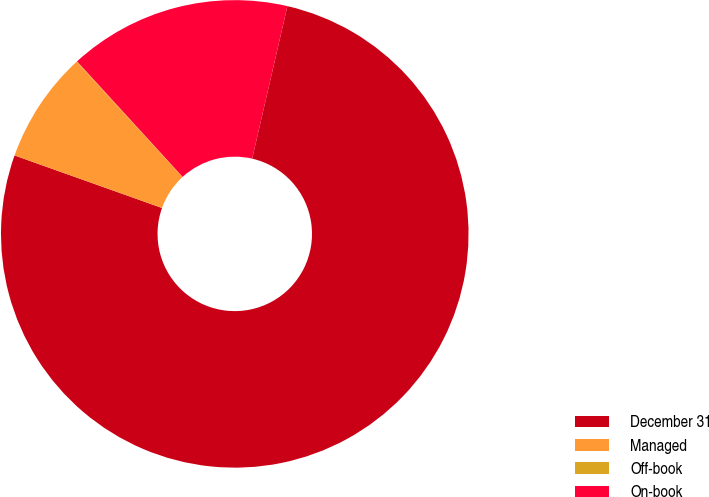Convert chart to OTSL. <chart><loc_0><loc_0><loc_500><loc_500><pie_chart><fcel>December 31<fcel>Managed<fcel>Off-book<fcel>On-book<nl><fcel>76.83%<fcel>7.72%<fcel>0.05%<fcel>15.4%<nl></chart> 